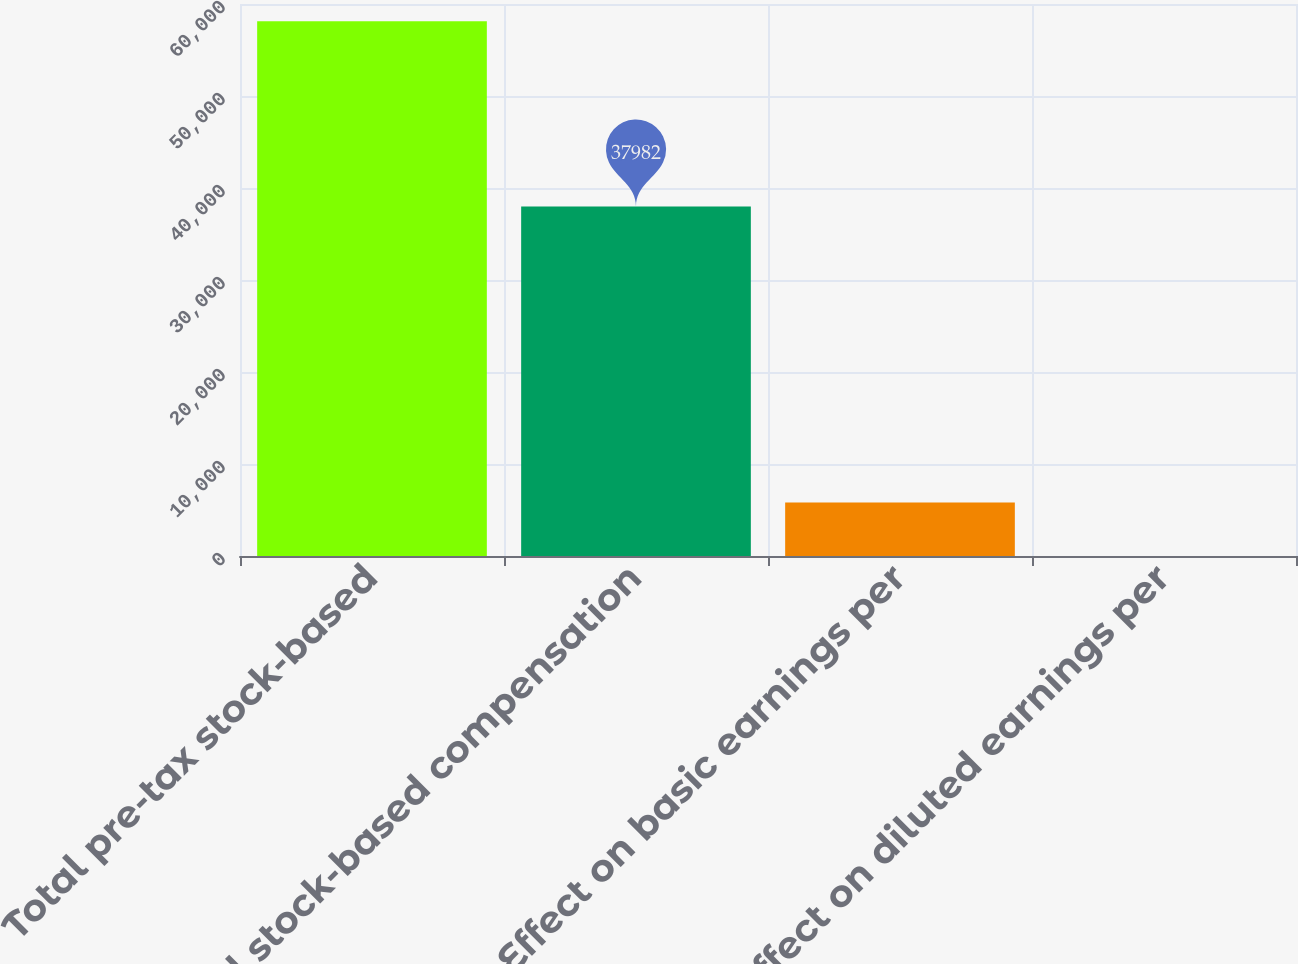Convert chart. <chart><loc_0><loc_0><loc_500><loc_500><bar_chart><fcel>Total pre-tax stock-based<fcel>Total stock-based compensation<fcel>Effect on basic earnings per<fcel>Effect on diluted earnings per<nl><fcel>58134<fcel>37982<fcel>5818.52<fcel>5.69<nl></chart> 